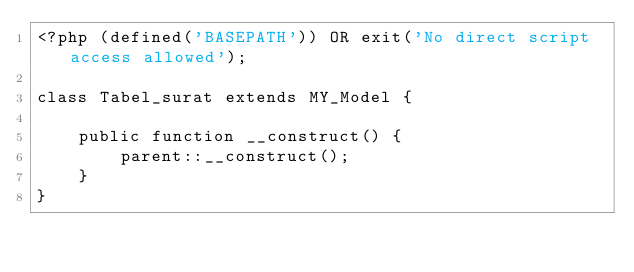Convert code to text. <code><loc_0><loc_0><loc_500><loc_500><_PHP_><?php (defined('BASEPATH')) OR exit('No direct script access allowed');

class Tabel_surat extends MY_Model {

    public function __construct() {
        parent::__construct();
    }
}</code> 